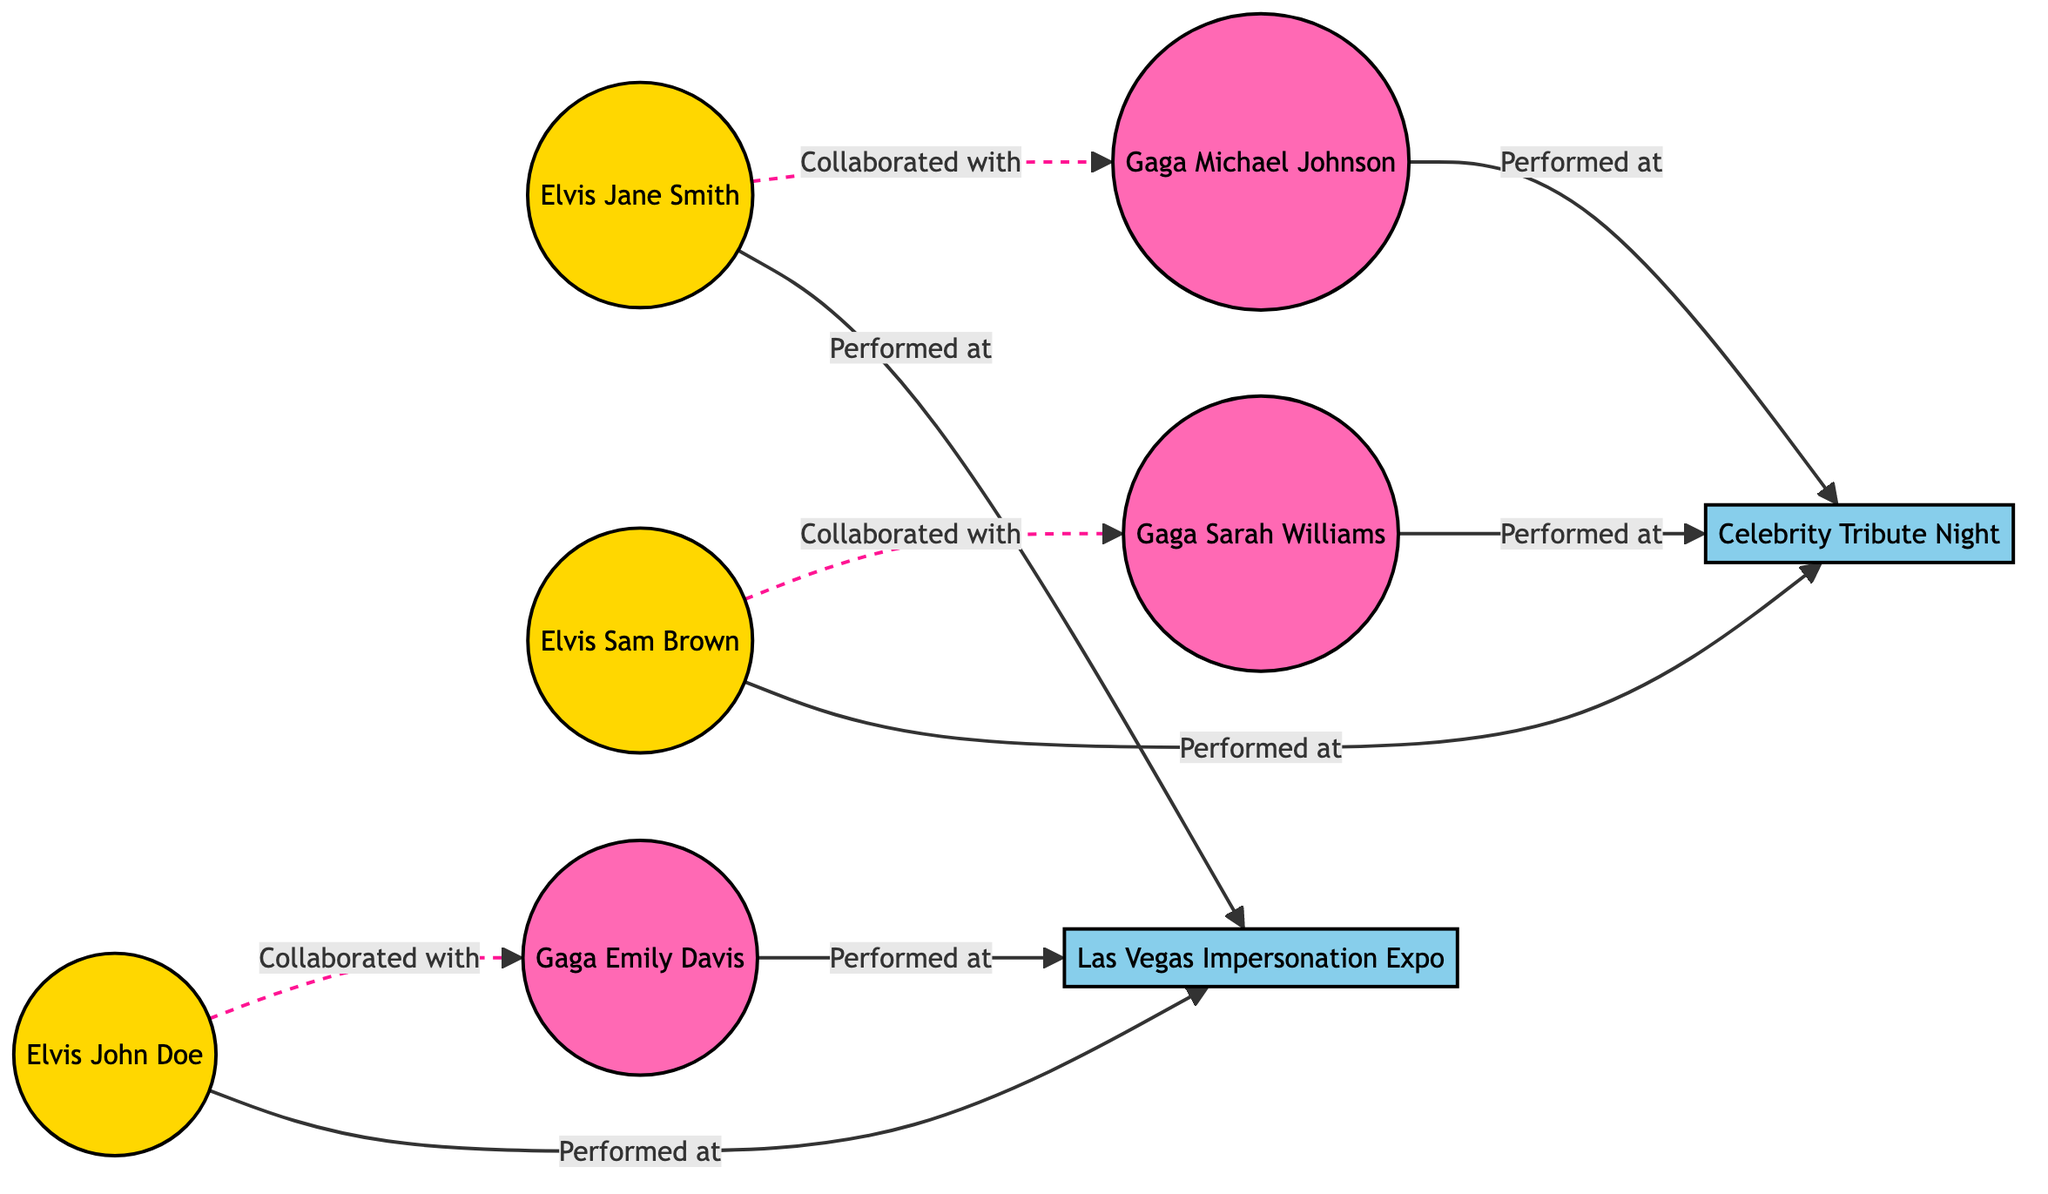What is the total number of impersonators in the diagram? In the diagram, we can count the number of nodes under the "Elvis" group and the "Gaga" group. There are 3 Elvis impersonators and 3 Gaga impersonators, which total to 6 impersonators.
Answer: 6 Which event does Elvis Impersonator Jane Smith perform at? Referring to the connections from nodes labeled "Elvis Impersonator Jane Smith," she is connected to the "Las Vegas Impersonation Expo" node with a "Performed at" relationship.
Answer: Las Vegas Impersonation Expo How many collaborations are shown between Elvis and Gaga impersonators? By examining the edges, we can see that there are 3 collaboration connections: each Elvis impersonator collaborates with one Gaga impersonator. Thus, the total number of collaborations is 3.
Answer: 3 Who performed at the "Celebrity Tribute Night"? Reviewing the edges connected to the "Celebrity Tribute Night" node, both "Elvis Impersonator Sam Brown" and "Gaga Impersonator Michael Johnson" and "Gaga Impersonator Sarah Williams" have a "Performed at" relationship with this event.
Answer: Sam Brown, Michael Johnson, Sarah Williams Which Lady Gaga impersonator collaborated with Elvis Impersonator John Doe? By following the connection from "Elvis Impersonator John Doe," he has a dashed connection indicating collaboration with "Gaga Impersonator Emily Davis."
Answer: Emily Davis What is the total number of edges (connections) in the diagram? To find the total number of edges, we count each connection listed in the edges section. There are 8 edges connecting impersonators and events in the diagram.
Answer: 8 What is the group of "Lady Gaga Impersonator Sarah Williams"? As per the node classification, "Lady Gaga Impersonator Sarah Williams" belongs to the group labeled "Gaga."
Answer: Gaga Which event is performed at by both Elvis and Gaga impersonators? Looking at the event connections, "Las Vegas Impersonation Expo" has connections from both Elvis impersonators and Gaga impersonators, indicating it is performed at by both groups.
Answer: Las Vegas Impersonation Expo 